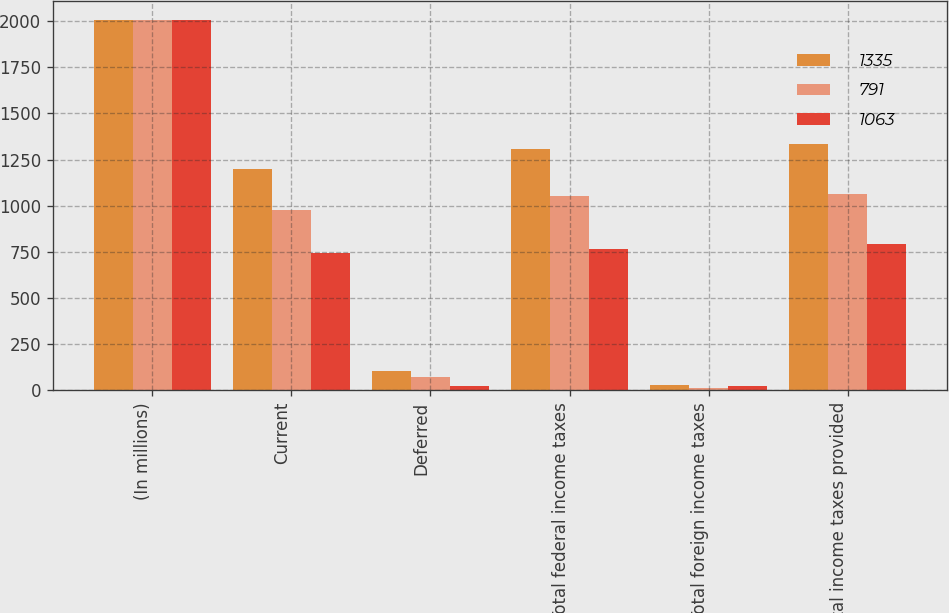<chart> <loc_0><loc_0><loc_500><loc_500><stacked_bar_chart><ecel><fcel>(In millions)<fcel>Current<fcel>Deferred<fcel>Total federal income taxes<fcel>Total foreign income taxes<fcel>Total income taxes provided<nl><fcel>1335<fcel>2007<fcel>1199<fcel>107<fcel>1306<fcel>29<fcel>1335<nl><fcel>791<fcel>2006<fcel>979<fcel>73<fcel>1052<fcel>11<fcel>1063<nl><fcel>1063<fcel>2005<fcel>742<fcel>24<fcel>766<fcel>25<fcel>791<nl></chart> 